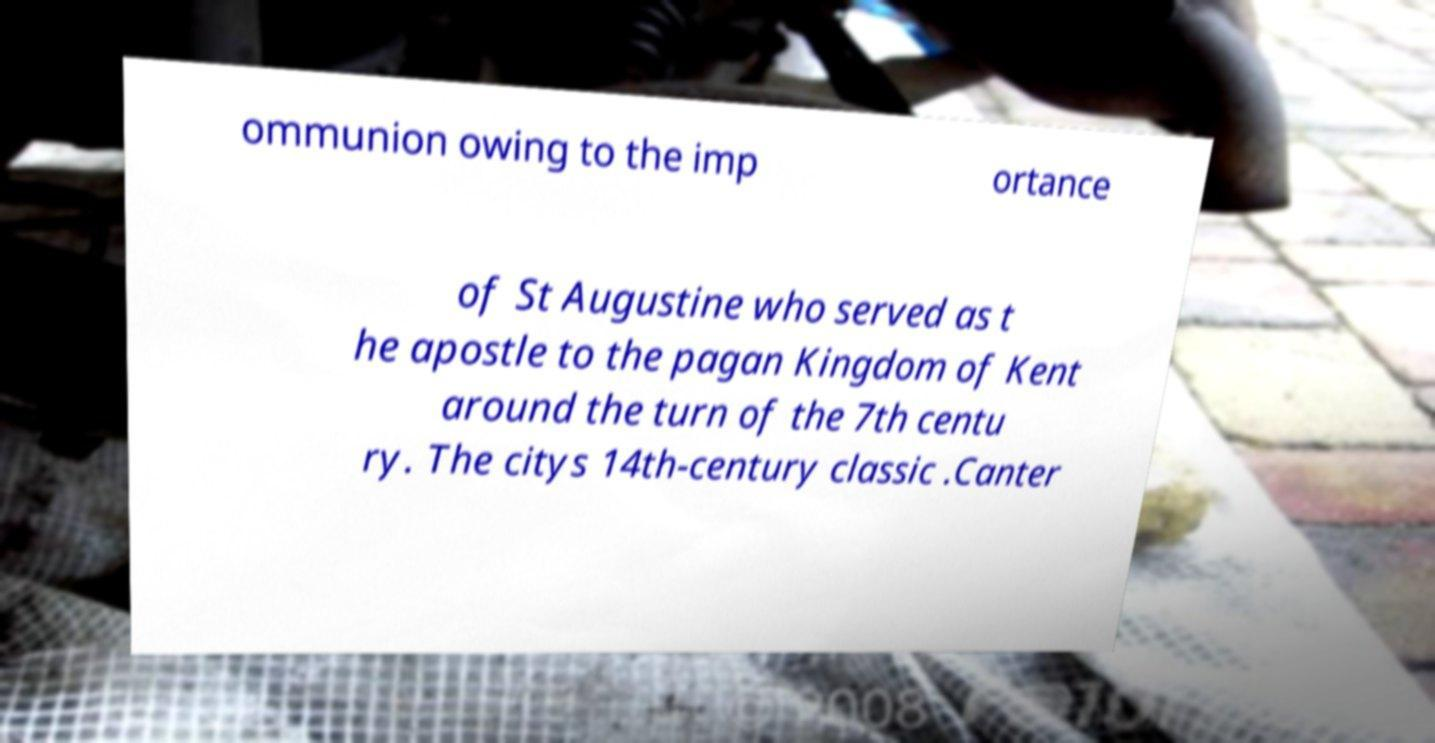Could you extract and type out the text from this image? ommunion owing to the imp ortance of St Augustine who served as t he apostle to the pagan Kingdom of Kent around the turn of the 7th centu ry. The citys 14th-century classic .Canter 